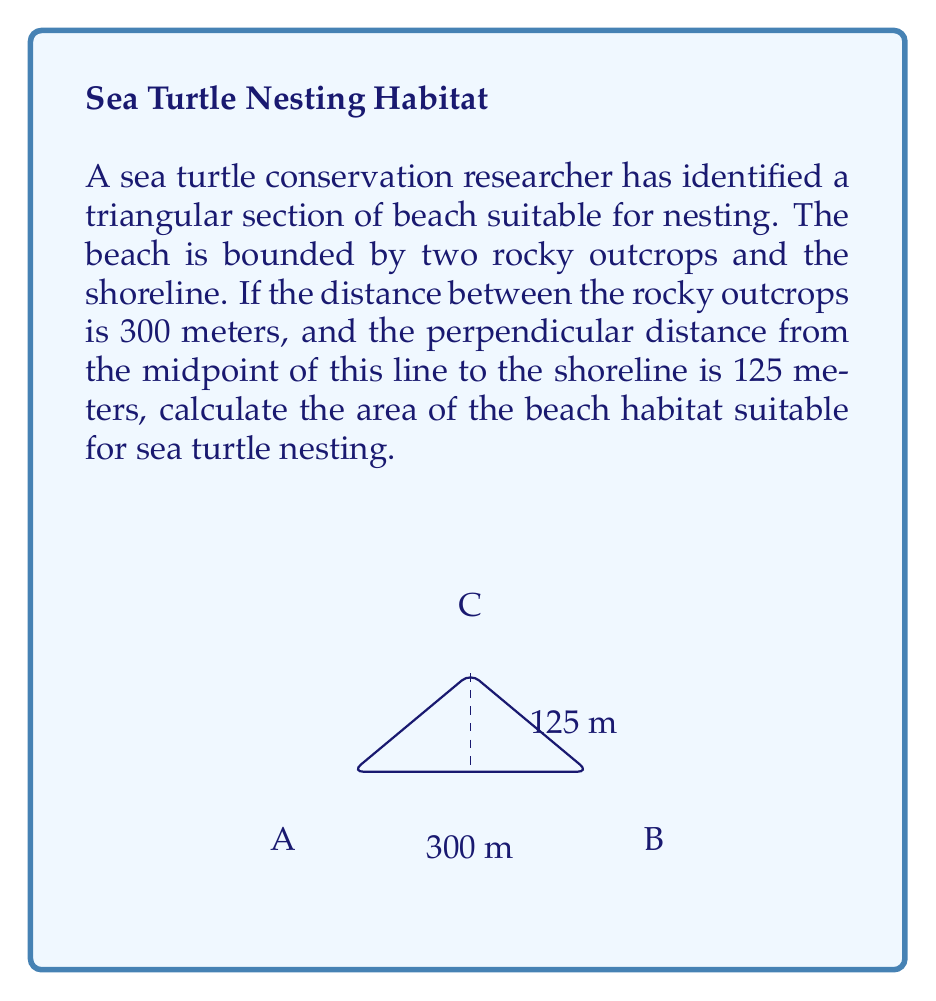Solve this math problem. Let's approach this step-by-step:

1) The beach forms a triangle. We can calculate its area using the formula:

   $$ \text{Area} = \frac{1}{2} \times \text{base} \times \text{height} $$

2) We are given:
   - The base (distance between rocky outcrops) is 300 meters
   - The height (perpendicular distance from midpoint to shoreline) is 125 meters

3) Plugging these values into our formula:

   $$ \text{Area} = \frac{1}{2} \times 300 \times 125 $$

4) Now let's calculate:

   $$ \text{Area} = \frac{1}{2} \times 37,500 = 18,750 $$

5) Therefore, the area of the beach habitat suitable for sea turtle nesting is 18,750 square meters.
Answer: 18,750 m² 